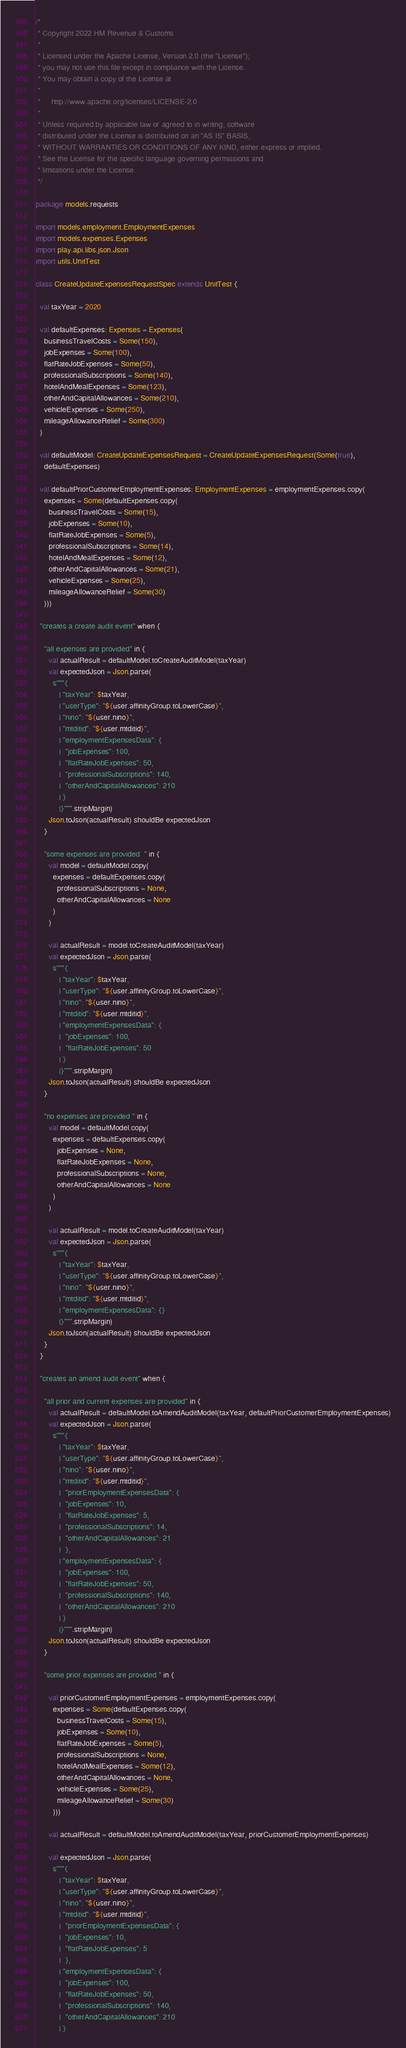<code> <loc_0><loc_0><loc_500><loc_500><_Scala_>/*
 * Copyright 2022 HM Revenue & Customs
 *
 * Licensed under the Apache License, Version 2.0 (the "License");
 * you may not use this file except in compliance with the License.
 * You may obtain a copy of the License at
 *
 *     http://www.apache.org/licenses/LICENSE-2.0
 *
 * Unless required by applicable law or agreed to in writing, software
 * distributed under the License is distributed on an "AS IS" BASIS,
 * WITHOUT WARRANTIES OR CONDITIONS OF ANY KIND, either express or implied.
 * See the License for the specific language governing permissions and
 * limitations under the License.
 */

package models.requests

import models.employment.EmploymentExpenses
import models.expenses.Expenses
import play.api.libs.json.Json
import utils.UnitTest

class CreateUpdateExpensesRequestSpec extends UnitTest {

  val taxYear = 2020

  val defaultExpenses: Expenses = Expenses(
    businessTravelCosts = Some(150),
    jobExpenses = Some(100),
    flatRateJobExpenses = Some(50),
    professionalSubscriptions = Some(140),
    hotelAndMealExpenses = Some(123),
    otherAndCapitalAllowances = Some(210),
    vehicleExpenses = Some(250),
    mileageAllowanceRelief = Some(300)
  )

  val defaultModel: CreateUpdateExpensesRequest = CreateUpdateExpensesRequest(Some(true),
    defaultExpenses)

  val defaultPriorCustomerEmploymentExpenses: EmploymentExpenses = employmentExpenses.copy(
    expenses = Some(defaultExpenses.copy(
      businessTravelCosts = Some(15),
      jobExpenses = Some(10),
      flatRateJobExpenses = Some(5),
      professionalSubscriptions = Some(14),
      hotelAndMealExpenses = Some(12),
      otherAndCapitalAllowances = Some(21),
      vehicleExpenses = Some(25),
      mileageAllowanceRelief = Some(30)
    )))

  "creates a create audit event" when {

    "all expenses are provided" in {
      val actualResult = defaultModel.toCreateAuditModel(taxYear)
      val expectedJson = Json.parse(
        s"""{
           | "taxYear": $taxYear,
           | "userType": "${user.affinityGroup.toLowerCase}",
           | "nino": "${user.nino}",
           | "mtditid": "${user.mtditid}",
           | "employmentExpensesData": {
           |  "jobExpenses": 100,
           |  "flatRateJobExpenses": 50,
           |  "professionalSubscriptions": 140,
           |  "otherAndCapitalAllowances": 210
           | }
           |}""".stripMargin)
      Json.toJson(actualResult) shouldBe expectedJson
    }

    "some expenses are provided  " in {
      val model = defaultModel.copy(
        expenses = defaultExpenses.copy(
          professionalSubscriptions = None,
          otherAndCapitalAllowances = None
        )
      )

      val actualResult = model.toCreateAuditModel(taxYear)
      val expectedJson = Json.parse(
        s"""{
           | "taxYear": $taxYear,
           | "userType": "${user.affinityGroup.toLowerCase}",
           | "nino": "${user.nino}",
           | "mtditid": "${user.mtditid}",
           | "employmentExpensesData": {
           |  "jobExpenses": 100,
           |  "flatRateJobExpenses": 50
           | }
           |}""".stripMargin)
      Json.toJson(actualResult) shouldBe expectedJson
    }

    "no expenses are provided " in {
      val model = defaultModel.copy(
        expenses = defaultExpenses.copy(
          jobExpenses = None,
          flatRateJobExpenses = None,
          professionalSubscriptions = None,
          otherAndCapitalAllowances = None
        )
      )

      val actualResult = model.toCreateAuditModel(taxYear)
      val expectedJson = Json.parse(
        s"""{
           | "taxYear": $taxYear,
           | "userType": "${user.affinityGroup.toLowerCase}",
           | "nino": "${user.nino}",
           | "mtditid": "${user.mtditid}",
           | "employmentExpensesData": {}
           |}""".stripMargin)
      Json.toJson(actualResult) shouldBe expectedJson
    }
  }

  "creates an amend audit event" when {

    "all prior and current expenses are provided" in {
      val actualResult = defaultModel.toAmendAuditModel(taxYear, defaultPriorCustomerEmploymentExpenses)
      val expectedJson = Json.parse(
        s"""{
           | "taxYear": $taxYear,
           | "userType": "${user.affinityGroup.toLowerCase}",
           | "nino": "${user.nino}",
           | "mtditid": "${user.mtditid}",
           |  "priorEmploymentExpensesData": {
           |  "jobExpenses": 10,
           |  "flatRateJobExpenses": 5,
           |  "professionalSubscriptions": 14,
           |  "otherAndCapitalAllowances": 21
           |  },
           | "employmentExpensesData": {
           |  "jobExpenses": 100,
           |  "flatRateJobExpenses": 50,
           |  "professionalSubscriptions": 140,
           |  "otherAndCapitalAllowances": 210
           | }
           |}""".stripMargin)
      Json.toJson(actualResult) shouldBe expectedJson
    }

    "some prior expenses are provided " in {

      val priorCustomerEmploymentExpenses = employmentExpenses.copy(
        expenses = Some(defaultExpenses.copy(
          businessTravelCosts = Some(15),
          jobExpenses = Some(10),
          flatRateJobExpenses = Some(5),
          professionalSubscriptions = None,
          hotelAndMealExpenses = Some(12),
          otherAndCapitalAllowances = None,
          vehicleExpenses = Some(25),
          mileageAllowanceRelief = Some(30)
        )))

      val actualResult = defaultModel.toAmendAuditModel(taxYear, priorCustomerEmploymentExpenses)

      val expectedJson = Json.parse(
        s"""{
           | "taxYear": $taxYear,
           | "userType": "${user.affinityGroup.toLowerCase}",
           | "nino": "${user.nino}",
           | "mtditid": "${user.mtditid}",
           |  "priorEmploymentExpensesData": {
           |  "jobExpenses": 10,
           |  "flatRateJobExpenses": 5
           |  },
           | "employmentExpensesData": {
           |  "jobExpenses": 100,
           |  "flatRateJobExpenses": 50,
           |  "professionalSubscriptions": 140,
           |  "otherAndCapitalAllowances": 210
           | }</code> 